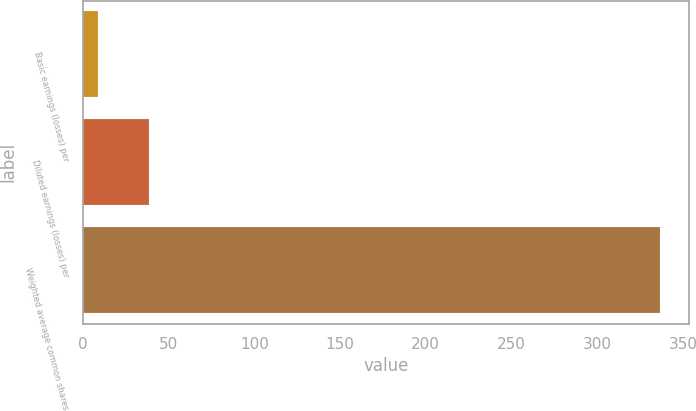Convert chart to OTSL. <chart><loc_0><loc_0><loc_500><loc_500><bar_chart><fcel>Basic earnings (losses) per<fcel>Diluted earnings (losses) per<fcel>Weighted average common shares<nl><fcel>8.99<fcel>38.76<fcel>336.47<nl></chart> 